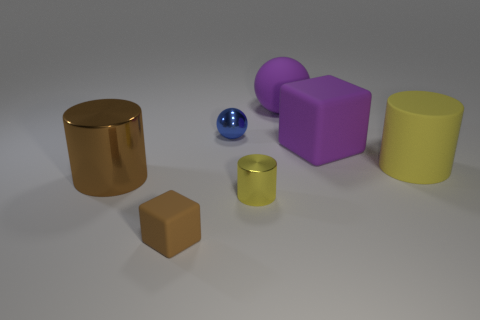Is the color of the small matte thing the same as the large matte cylinder?
Give a very brief answer. No. What color is the rubber thing that is in front of the large shiny cylinder that is behind the tiny brown rubber cube?
Your response must be concise. Brown. What number of tiny objects are either objects or blue metal things?
Keep it short and to the point. 3. What is the color of the cylinder that is both to the right of the big brown metal object and in front of the large yellow thing?
Your answer should be very brief. Yellow. Does the big yellow cylinder have the same material as the blue object?
Your answer should be compact. No. The yellow matte object has what shape?
Your answer should be compact. Cylinder. What number of large matte objects are to the left of the rubber cube that is behind the metal thing left of the metallic ball?
Your answer should be very brief. 1. There is another tiny metallic thing that is the same shape as the brown metal thing; what color is it?
Offer a very short reply. Yellow. The big rubber object behind the matte cube that is behind the yellow thing to the left of the big yellow thing is what shape?
Ensure brevity in your answer.  Sphere. How big is the thing that is to the right of the large brown metal cylinder and to the left of the blue metal sphere?
Provide a succinct answer. Small. 